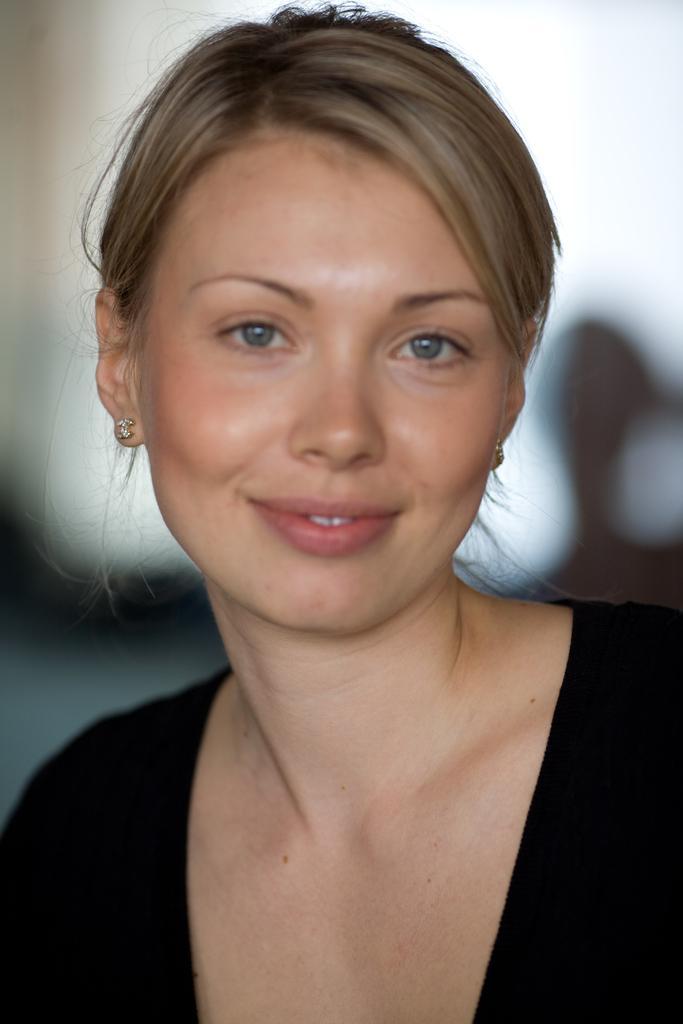Please provide a concise description of this image. In this image we can see one woman in the black dress and the background is blurred. 